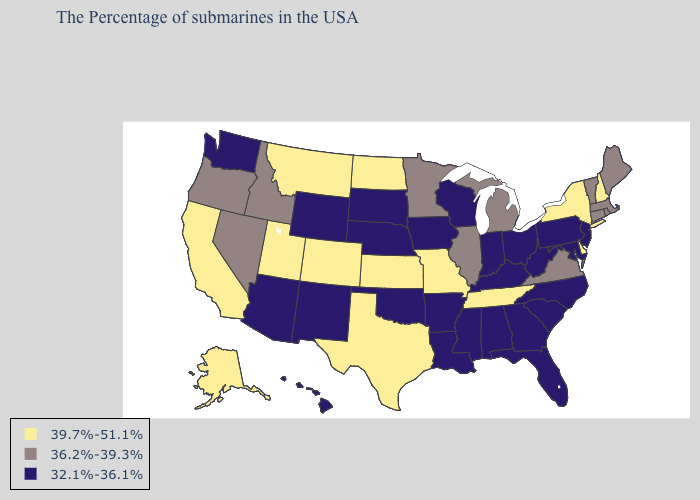What is the highest value in the South ?
Short answer required. 39.7%-51.1%. What is the lowest value in states that border New York?
Keep it brief. 32.1%-36.1%. What is the value of Oregon?
Quick response, please. 36.2%-39.3%. Which states hav the highest value in the Northeast?
Give a very brief answer. New Hampshire, New York. Does Connecticut have a lower value than Minnesota?
Quick response, please. No. Name the states that have a value in the range 32.1%-36.1%?
Keep it brief. New Jersey, Maryland, Pennsylvania, North Carolina, South Carolina, West Virginia, Ohio, Florida, Georgia, Kentucky, Indiana, Alabama, Wisconsin, Mississippi, Louisiana, Arkansas, Iowa, Nebraska, Oklahoma, South Dakota, Wyoming, New Mexico, Arizona, Washington, Hawaii. Among the states that border North Dakota , which have the highest value?
Be succinct. Montana. Among the states that border Florida , which have the lowest value?
Quick response, please. Georgia, Alabama. Among the states that border Pennsylvania , which have the lowest value?
Concise answer only. New Jersey, Maryland, West Virginia, Ohio. Among the states that border Colorado , which have the lowest value?
Keep it brief. Nebraska, Oklahoma, Wyoming, New Mexico, Arizona. Which states have the lowest value in the USA?
Write a very short answer. New Jersey, Maryland, Pennsylvania, North Carolina, South Carolina, West Virginia, Ohio, Florida, Georgia, Kentucky, Indiana, Alabama, Wisconsin, Mississippi, Louisiana, Arkansas, Iowa, Nebraska, Oklahoma, South Dakota, Wyoming, New Mexico, Arizona, Washington, Hawaii. What is the value of Minnesota?
Short answer required. 36.2%-39.3%. What is the value of Alaska?
Concise answer only. 39.7%-51.1%. Name the states that have a value in the range 32.1%-36.1%?
Short answer required. New Jersey, Maryland, Pennsylvania, North Carolina, South Carolina, West Virginia, Ohio, Florida, Georgia, Kentucky, Indiana, Alabama, Wisconsin, Mississippi, Louisiana, Arkansas, Iowa, Nebraska, Oklahoma, South Dakota, Wyoming, New Mexico, Arizona, Washington, Hawaii. Among the states that border Massachusetts , does Connecticut have the lowest value?
Concise answer only. Yes. 